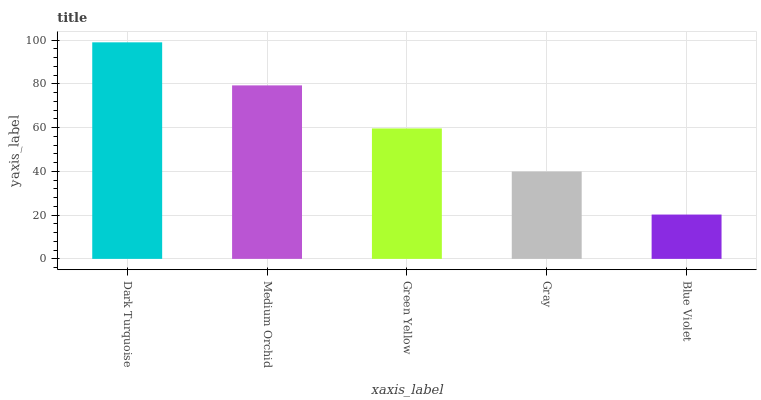Is Medium Orchid the minimum?
Answer yes or no. No. Is Medium Orchid the maximum?
Answer yes or no. No. Is Dark Turquoise greater than Medium Orchid?
Answer yes or no. Yes. Is Medium Orchid less than Dark Turquoise?
Answer yes or no. Yes. Is Medium Orchid greater than Dark Turquoise?
Answer yes or no. No. Is Dark Turquoise less than Medium Orchid?
Answer yes or no. No. Is Green Yellow the high median?
Answer yes or no. Yes. Is Green Yellow the low median?
Answer yes or no. Yes. Is Gray the high median?
Answer yes or no. No. Is Medium Orchid the low median?
Answer yes or no. No. 